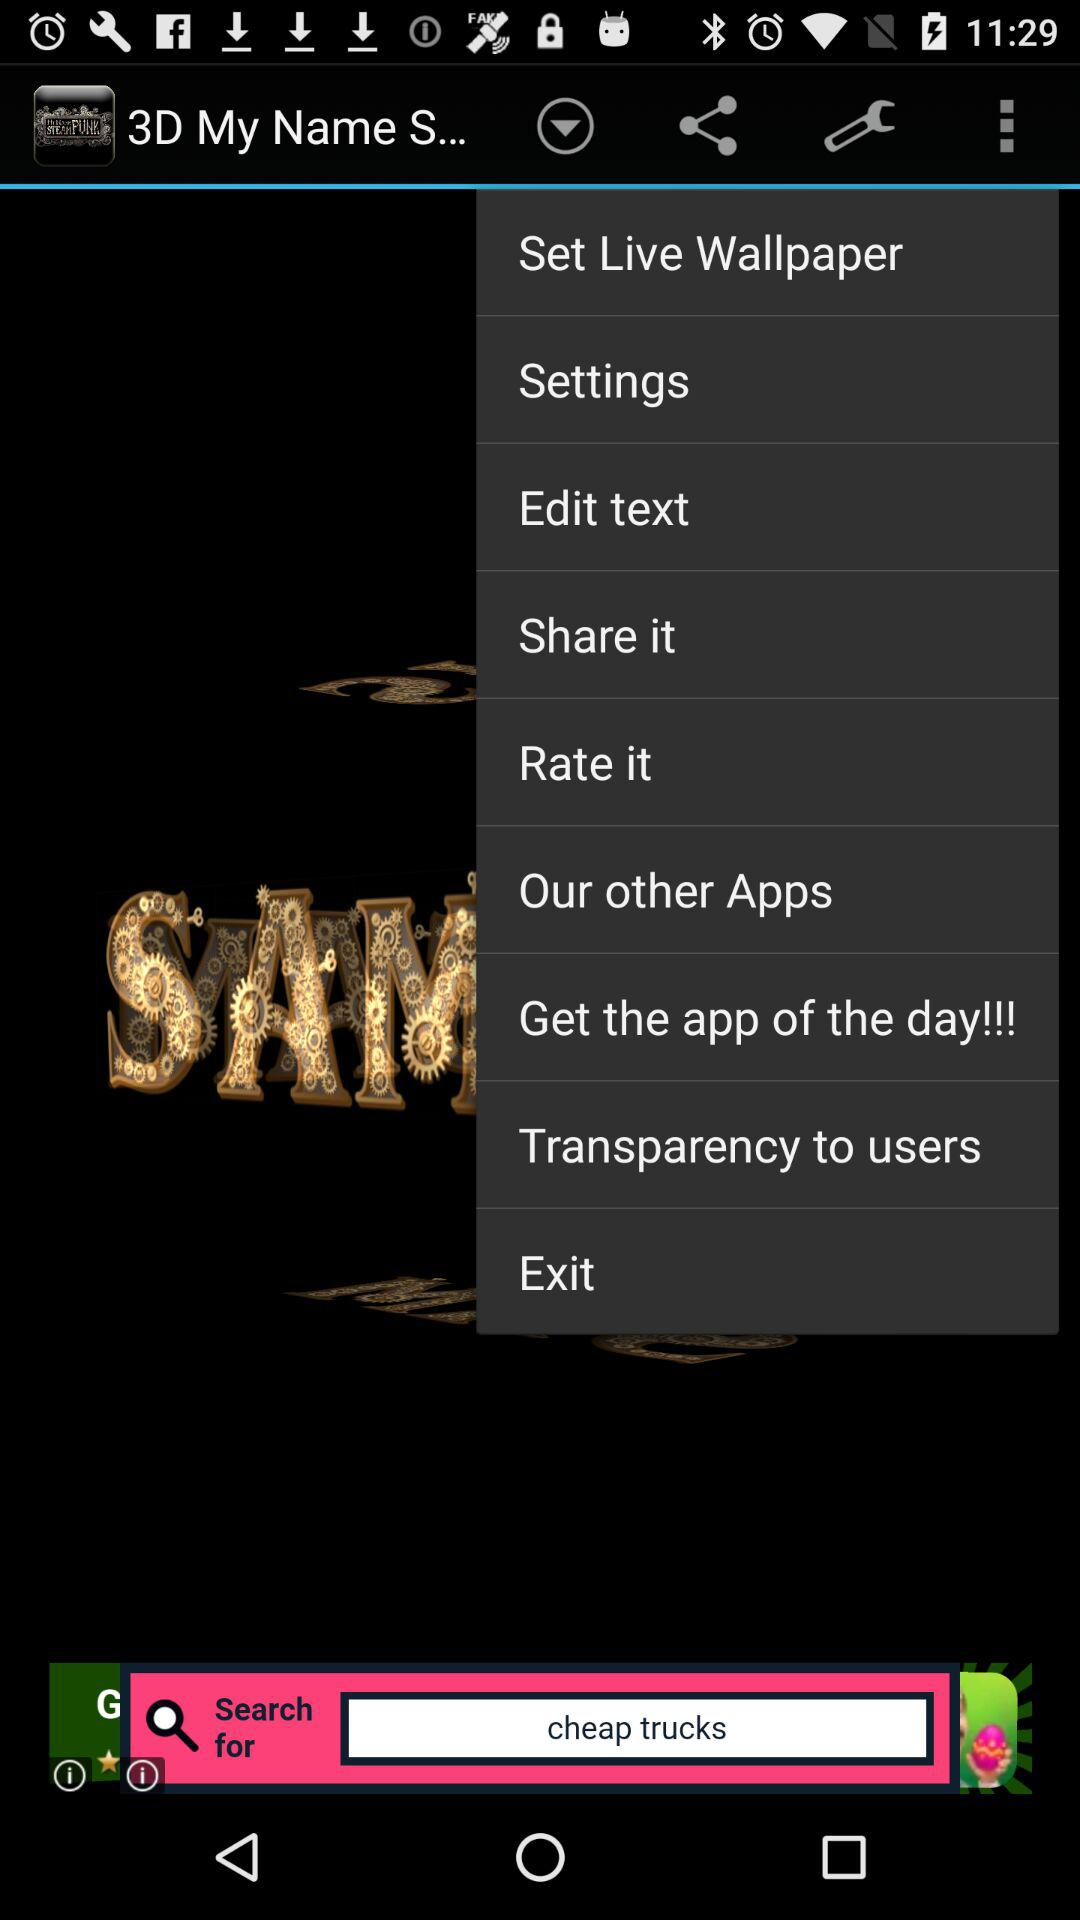What is the application name? The application name is "3D My Name Steampunk Fonts LWP". 